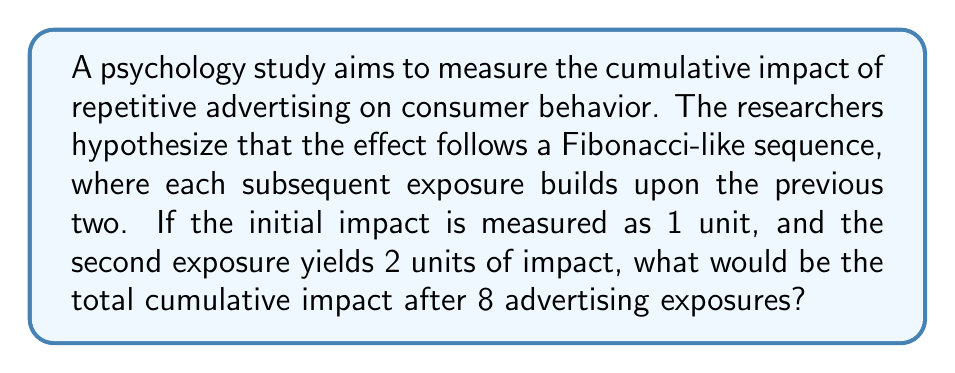Help me with this question. To solve this problem, we need to follow these steps:

1. Recognize that we're dealing with a Fibonacci-like sequence where each term is the sum of the two preceding ones.

2. Write out the sequence for 8 terms:
   $F_1 = 1$
   $F_2 = 2$
   $F_3 = F_1 + F_2 = 1 + 2 = 3$
   $F_4 = F_2 + F_3 = 2 + 3 = 5$
   $F_5 = F_3 + F_4 = 3 + 5 = 8$
   $F_6 = F_4 + F_5 = 5 + 8 = 13$
   $F_7 = F_5 + F_6 = 8 + 13 = 21$
   $F_8 = F_6 + F_7 = 13 + 21 = 34$

3. To find the cumulative impact, we need to sum all these terms:

   $$\sum_{i=1}^{8} F_i = 1 + 2 + 3 + 5 + 8 + 13 + 21 + 34 = 87$$

4. Therefore, the total cumulative impact after 8 advertising exposures is 87 units.

This result demonstrates how the impact of repetitive advertising can grow rapidly, following a Fibonacci-like pattern, which could be valuable insight for a psychologist studying the effects of media consumption on consumer behavior.
Answer: 87 units 